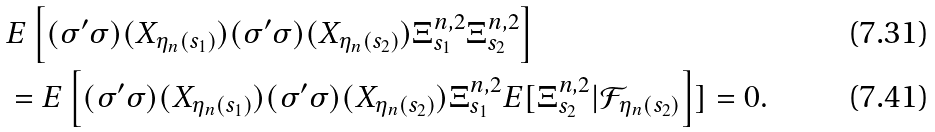Convert formula to latex. <formula><loc_0><loc_0><loc_500><loc_500>& E \left [ ( \sigma ^ { \prime } \sigma ) ( X _ { \eta _ { n } ( s _ { 1 } ) } ) ( \sigma ^ { \prime } \sigma ) ( X _ { \eta _ { n } ( s _ { 2 } ) } ) \Xi ^ { n , 2 } _ { s _ { 1 } } \Xi ^ { n , 2 } _ { s _ { 2 } } \right ] \\ & = E \left [ ( \sigma ^ { \prime } \sigma ) ( X _ { \eta _ { n } ( s _ { 1 } ) } ) ( \sigma ^ { \prime } \sigma ) ( X _ { \eta _ { n } ( s _ { 2 } ) } ) \Xi ^ { n , 2 } _ { s _ { 1 } } E [ \Xi ^ { n , 2 } _ { s _ { 2 } } | \mathcal { F } _ { \eta _ { n } ( s _ { 2 } ) } \right ] ] = 0 .</formula> 